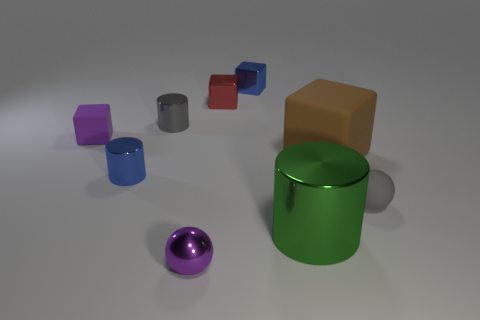Are there any blue things that have the same shape as the large brown object?
Provide a short and direct response. Yes. There is a tiny metallic sphere; does it have the same color as the rubber object left of the gray metallic thing?
Give a very brief answer. Yes. There is a thing that is the same color as the small matte sphere; what is its size?
Give a very brief answer. Small. Are there any objects that have the same size as the green cylinder?
Your answer should be very brief. Yes. Is the small gray cylinder made of the same material as the purple thing behind the big cube?
Provide a succinct answer. No. Are there more purple shiny things than small gray shiny blocks?
Keep it short and to the point. Yes. How many spheres are big objects or big brown objects?
Give a very brief answer. 0. What is the color of the large rubber cube?
Give a very brief answer. Brown. Do the blue thing that is on the left side of the small metallic ball and the gray thing that is to the left of the tiny gray sphere have the same size?
Your response must be concise. Yes. Is the number of big brown rubber objects less than the number of yellow metal spheres?
Provide a short and direct response. No. 